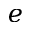<formula> <loc_0><loc_0><loc_500><loc_500>e</formula> 